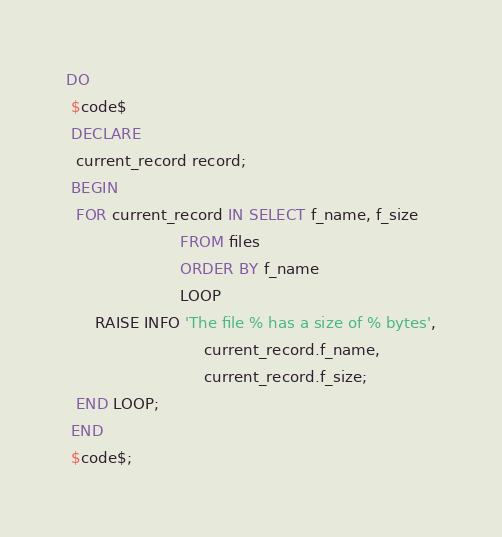<code> <loc_0><loc_0><loc_500><loc_500><_SQL_>DO
 $code$
 DECLARE
  current_record record;
 BEGIN
  FOR current_record IN SELECT f_name, f_size
                        FROM files
                        ORDER BY f_name
                        LOOP
      RAISE INFO 'The file % has a size of % bytes',
                             current_record.f_name,
                             current_record.f_size;
  END LOOP;
 END
 $code$;
</code> 